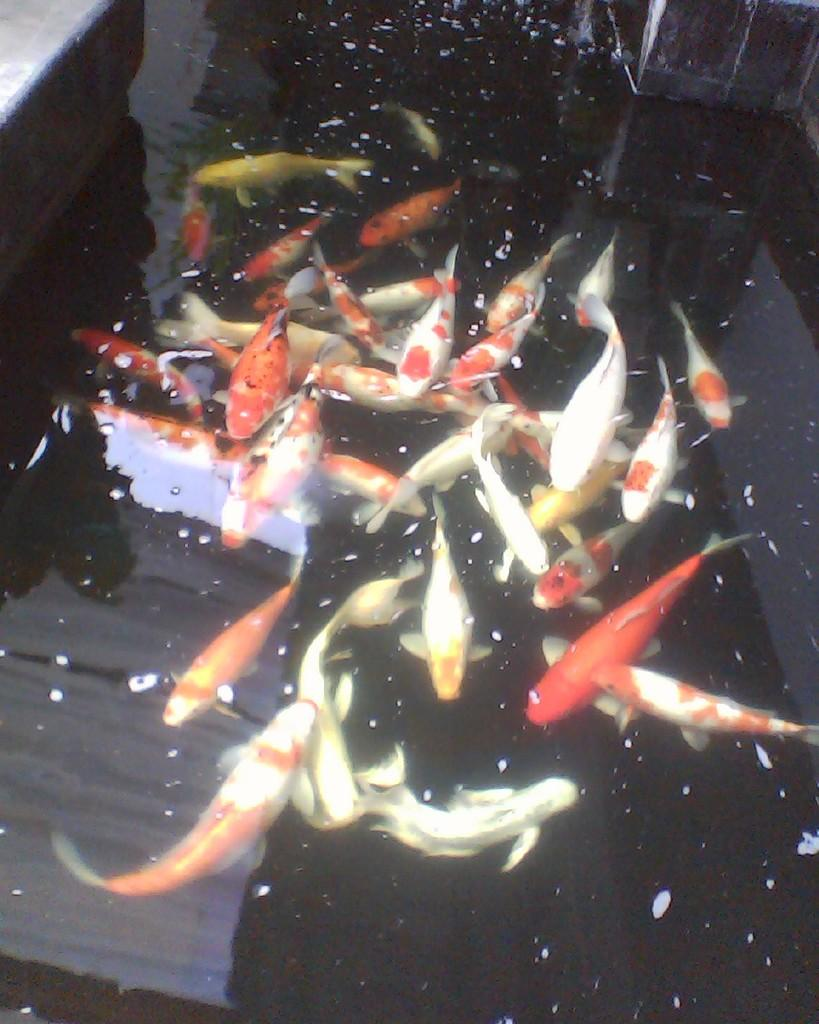What type of animals can be seen in the image? There are fishes in the image. Where are the fishes located? The fishes are in a water body. What type of skate is the father using for dinner in the image? There is no skate or father present in the image, and therefore no such activity can be observed. 